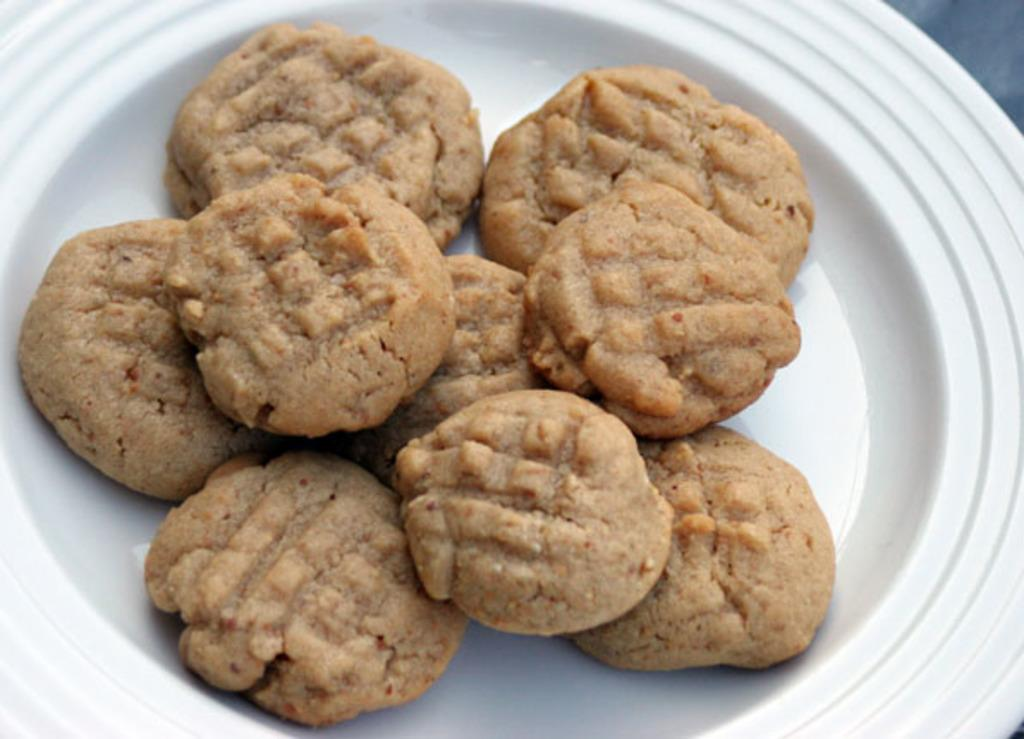What type of food is present in the image? There are cookies in the image. In what type of container are the cookies placed? The cookies are in a white color bowl. How do the cookies control the traffic in the image? The cookies do not control traffic in the image, as there is no mention of traffic or any related elements in the provided facts. 